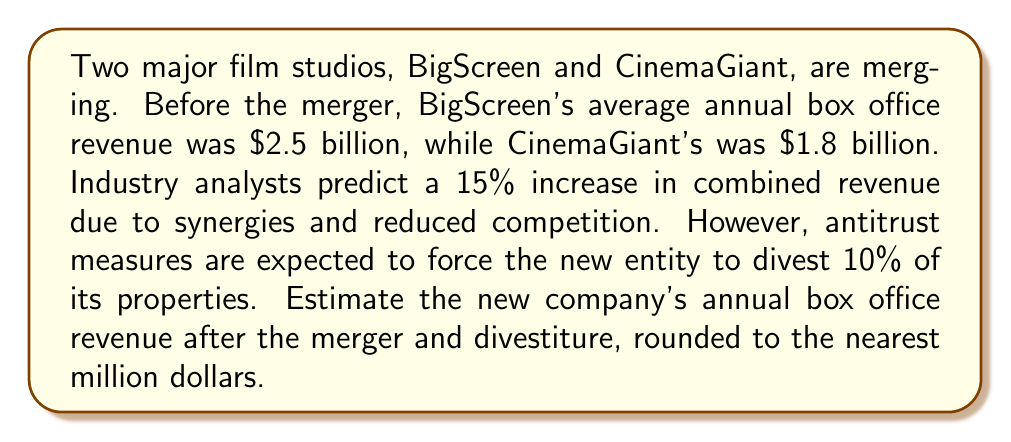Can you solve this math problem? Let's approach this step-by-step:

1) First, calculate the combined revenue of both studios before the merger:
   $$2.5\text{ billion} + 1.8\text{ billion} = 4.3\text{ billion}$$

2) Apply the 15% increase due to synergies and reduced competition:
   $$4.3\text{ billion} \times 1.15 = 4.945\text{ billion}$$

3) Now, account for the 10% divestiture:
   $$4.945\text{ billion} \times 0.90 = 4.4505\text{ billion}$$

4) Round to the nearest million:
   $$4.4505\text{ billion} \approx 4.451\text{ billion}$$
Answer: $4.451 billion 